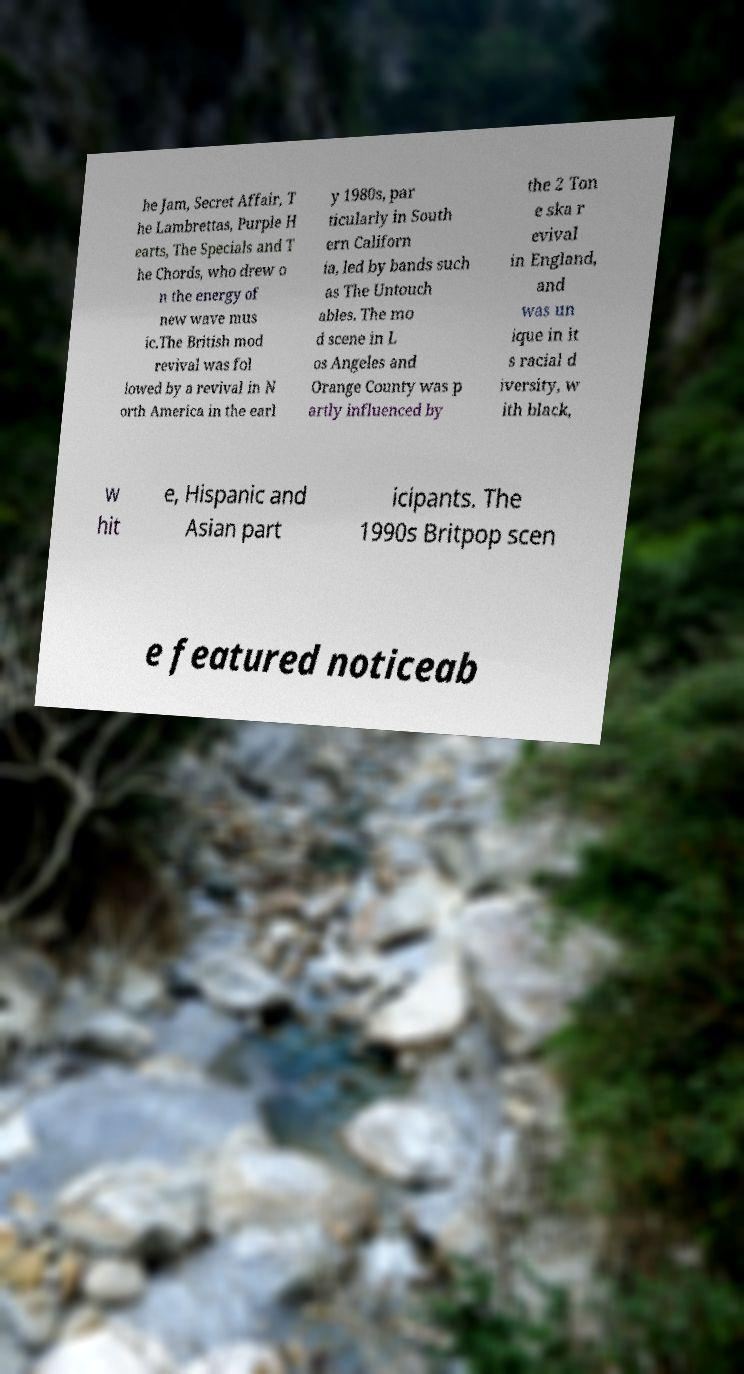Please read and relay the text visible in this image. What does it say? he Jam, Secret Affair, T he Lambrettas, Purple H earts, The Specials and T he Chords, who drew o n the energy of new wave mus ic.The British mod revival was fol lowed by a revival in N orth America in the earl y 1980s, par ticularly in South ern Californ ia, led by bands such as The Untouch ables. The mo d scene in L os Angeles and Orange County was p artly influenced by the 2 Ton e ska r evival in England, and was un ique in it s racial d iversity, w ith black, w hit e, Hispanic and Asian part icipants. The 1990s Britpop scen e featured noticeab 